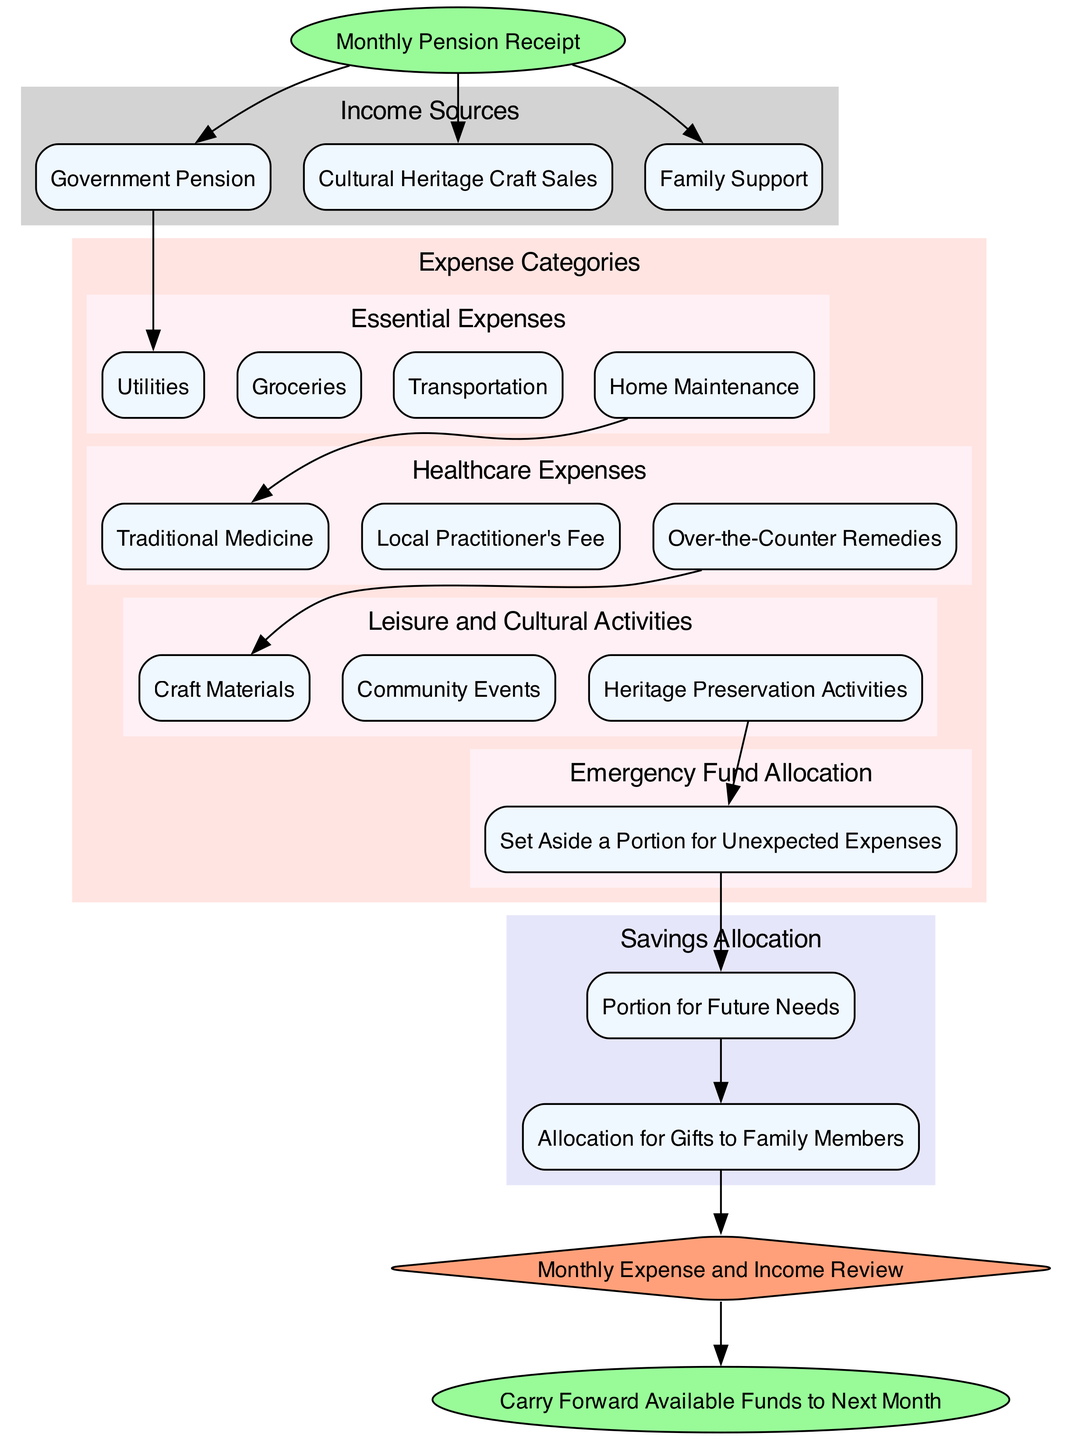What is the starting point of the flow chart? The flow chart begins with "Monthly Pension Receipt," which is indicated as the initial node of the diagram.
Answer: Monthly Pension Receipt How many income sources are listed? The diagram displays three distinct income sources under the "Income Sources" category: Government Pension, Cultural Heritage Craft Sales, and Family Support. Counting these sources gives us a total of three.
Answer: 3 What are the essential expenses listed in the diagram? The essential expenses consist of four items: Utilities, Groceries, Transportation, and Home Maintenance. These can be found in the "Essential Expenses" section of the diagram.
Answer: Utilities, Groceries, Transportation, Home Maintenance Which expense category follows healthcare expenses in the flow? Following "Healthcare Expenses," the next category in the flow chart is "Leisure and Cultural Activities." This relationship can be traced through the connecting edges in the diagram.
Answer: Leisure and Cultural Activities What should be set aside for unexpected expenses? The flow chart indicates that a portion should be set aside for "Emergency Fund Allocation," which is specifically mentioned as part of the expense categories.
Answer: Set Aside a Portion for Unexpected Expenses What is linked directly after the Gifting Fund? The Gifting Fund node connects directly to the "Review and Adjustment" node, establishing a flow from savings allocation to review processes in financial management.
Answer: Review and Adjustment How many total nodes represent healthcare expenses in the diagram? There are three items listed under "Healthcare Expenses," each represented by a separate node in the diagram, therefore totaling three nodes.
Answer: 3 Which categories are included in the "Savings Allocation"? The "Savings Allocation" includes two categories: "Monthly Savings" and "Gifting Fund," each represented as nodes within that specific section of the diagram.
Answer: Monthly Savings, Gifting Fund What is the final node of the flow chart? The flow chart culminates in the "Carry Forward Available Funds to Next Month," which is presented as the concluding node of the diagram after all prior categories have been processed.
Answer: Carry Forward Available Funds to Next Month 